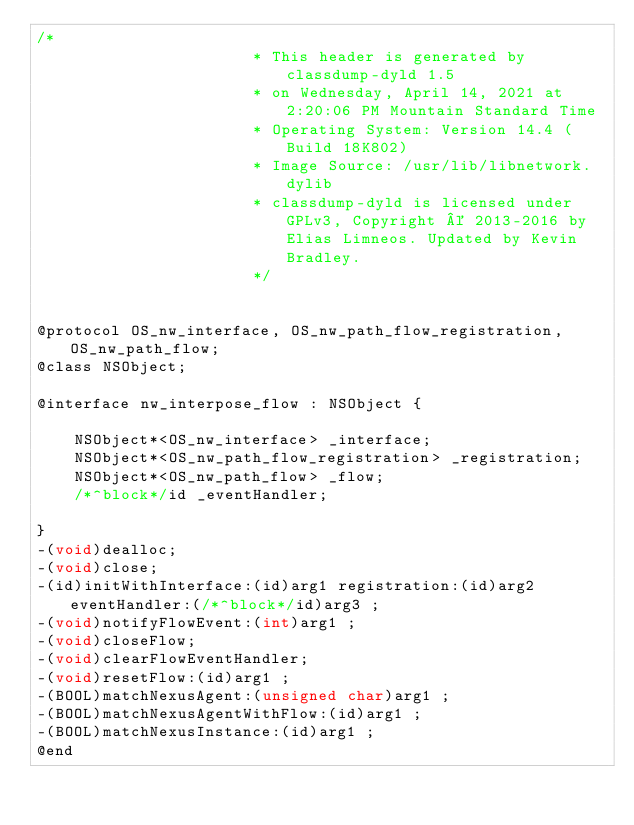Convert code to text. <code><loc_0><loc_0><loc_500><loc_500><_C_>/*
                       * This header is generated by classdump-dyld 1.5
                       * on Wednesday, April 14, 2021 at 2:20:06 PM Mountain Standard Time
                       * Operating System: Version 14.4 (Build 18K802)
                       * Image Source: /usr/lib/libnetwork.dylib
                       * classdump-dyld is licensed under GPLv3, Copyright © 2013-2016 by Elias Limneos. Updated by Kevin Bradley.
                       */


@protocol OS_nw_interface, OS_nw_path_flow_registration, OS_nw_path_flow;
@class NSObject;

@interface nw_interpose_flow : NSObject {

	NSObject*<OS_nw_interface> _interface;
	NSObject*<OS_nw_path_flow_registration> _registration;
	NSObject*<OS_nw_path_flow> _flow;
	/*^block*/id _eventHandler;

}
-(void)dealloc;
-(void)close;
-(id)initWithInterface:(id)arg1 registration:(id)arg2 eventHandler:(/*^block*/id)arg3 ;
-(void)notifyFlowEvent:(int)arg1 ;
-(void)closeFlow;
-(void)clearFlowEventHandler;
-(void)resetFlow:(id)arg1 ;
-(BOOL)matchNexusAgent:(unsigned char)arg1 ;
-(BOOL)matchNexusAgentWithFlow:(id)arg1 ;
-(BOOL)matchNexusInstance:(id)arg1 ;
@end

</code> 